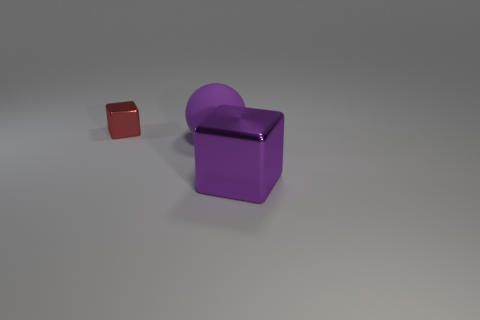Add 2 small yellow rubber cylinders. How many objects exist? 5 Subtract all blocks. How many objects are left? 1 Subtract 0 brown spheres. How many objects are left? 3 Subtract all big purple rubber objects. Subtract all purple balls. How many objects are left? 1 Add 3 red cubes. How many red cubes are left? 4 Add 1 red cubes. How many red cubes exist? 2 